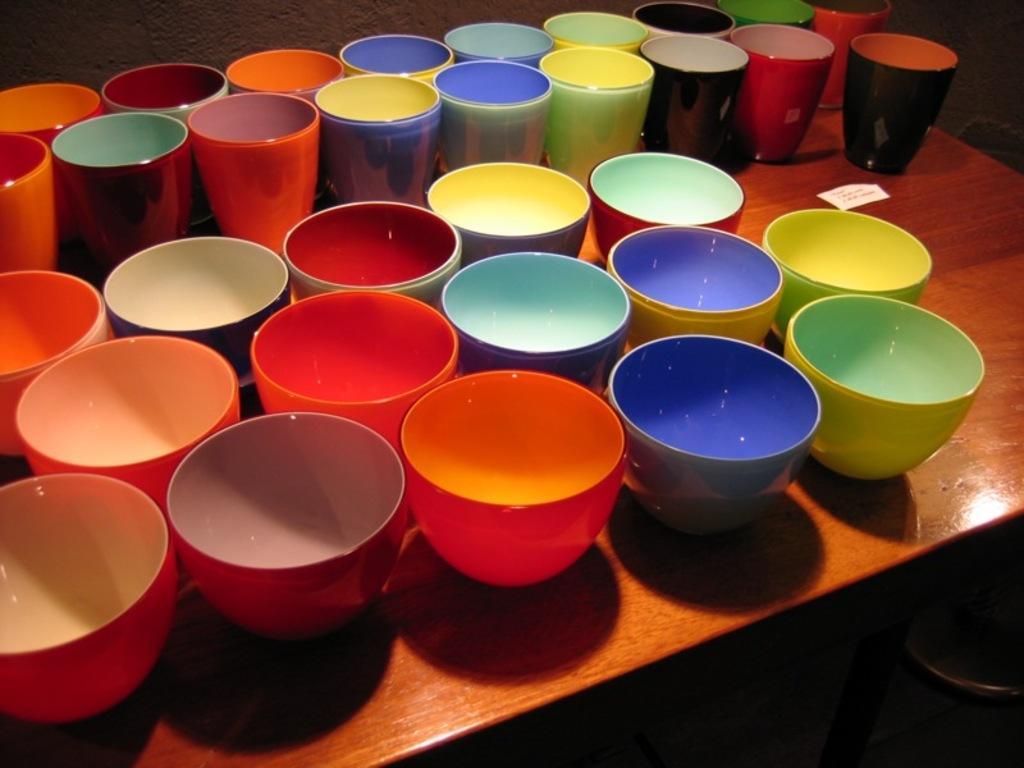Can you describe this image briefly? In the center of the image there is a table on which there are many cups and mugs. 